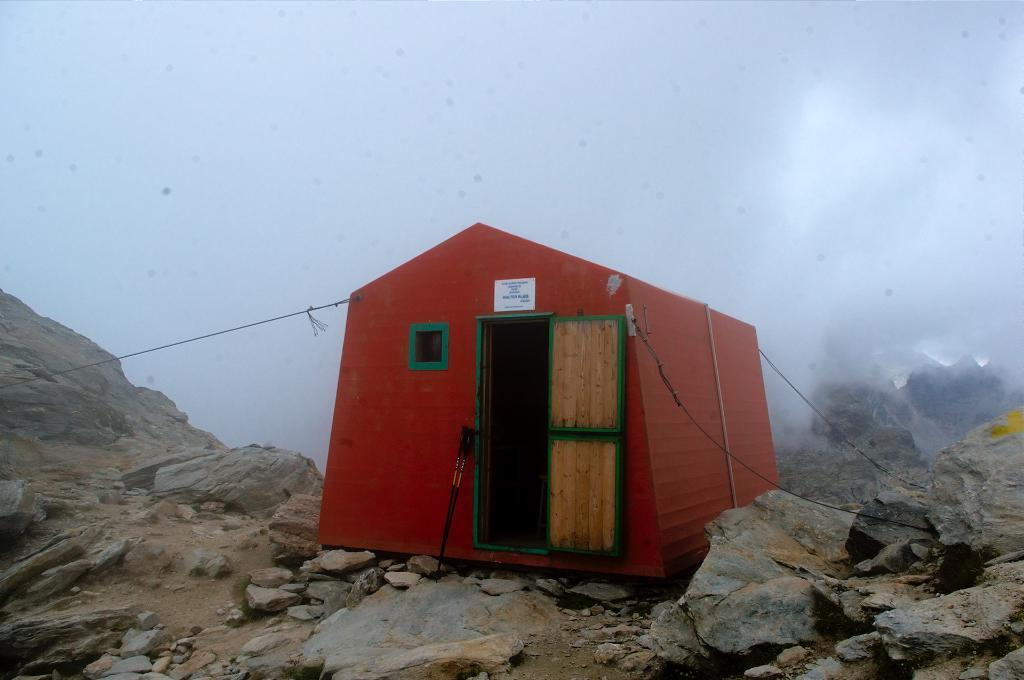What structure is located in the foreground of the image? There is a wooden shed in the foreground of the image. Where is the wooden shed situated? The wooden shed is on a mountain. What time of day is the image taken? The image is taken during the day. What can be seen in the background of the image? The sky is visible in the background of the image. How many girls are holding sparkling pies in the image? There are no girls or pies present in the image. 